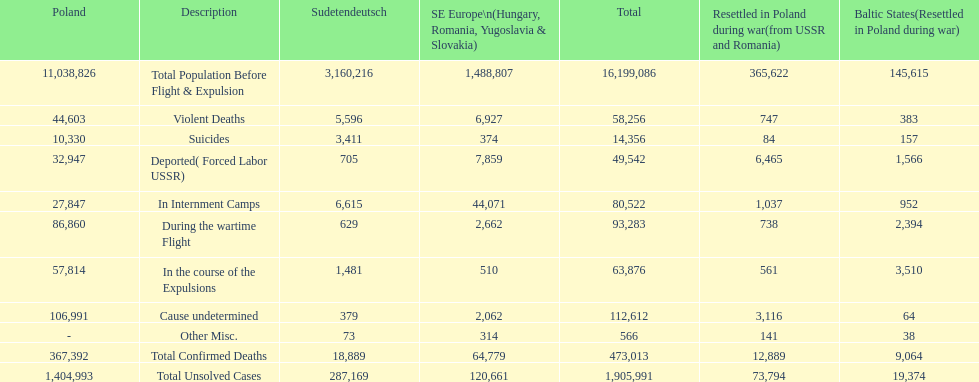What is the total of deaths in internment camps and during the wartime flight? 173,805. 